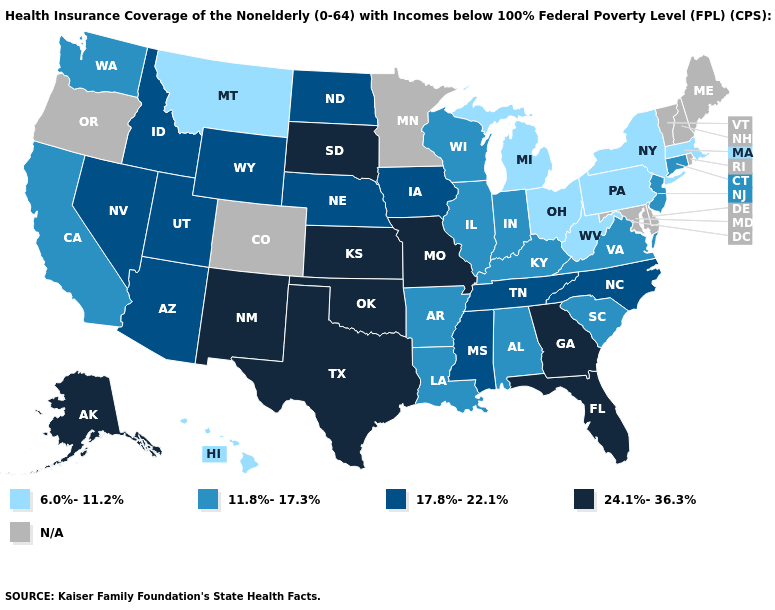What is the highest value in the South ?
Answer briefly. 24.1%-36.3%. Among the states that border Delaware , which have the highest value?
Quick response, please. New Jersey. What is the lowest value in the USA?
Keep it brief. 6.0%-11.2%. Which states have the highest value in the USA?
Be succinct. Alaska, Florida, Georgia, Kansas, Missouri, New Mexico, Oklahoma, South Dakota, Texas. Does the first symbol in the legend represent the smallest category?
Answer briefly. Yes. Which states hav the highest value in the Northeast?
Keep it brief. Connecticut, New Jersey. What is the value of Oregon?
Answer briefly. N/A. Which states have the highest value in the USA?
Keep it brief. Alaska, Florida, Georgia, Kansas, Missouri, New Mexico, Oklahoma, South Dakota, Texas. Among the states that border Minnesota , does South Dakota have the lowest value?
Concise answer only. No. Name the states that have a value in the range 24.1%-36.3%?
Concise answer only. Alaska, Florida, Georgia, Kansas, Missouri, New Mexico, Oklahoma, South Dakota, Texas. Name the states that have a value in the range 17.8%-22.1%?
Concise answer only. Arizona, Idaho, Iowa, Mississippi, Nebraska, Nevada, North Carolina, North Dakota, Tennessee, Utah, Wyoming. What is the value of Florida?
Give a very brief answer. 24.1%-36.3%. What is the lowest value in the USA?
Be succinct. 6.0%-11.2%. Among the states that border Florida , which have the lowest value?
Keep it brief. Alabama. 